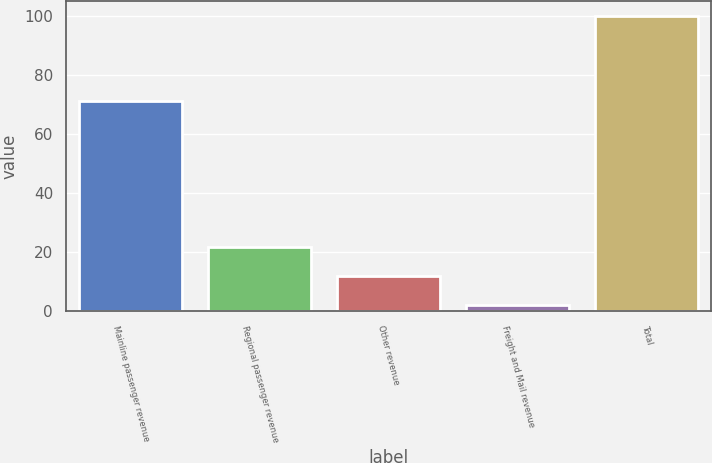Convert chart to OTSL. <chart><loc_0><loc_0><loc_500><loc_500><bar_chart><fcel>Mainline passenger revenue<fcel>Regional passenger revenue<fcel>Other revenue<fcel>Freight and Mail revenue<fcel>Total<nl><fcel>71<fcel>21.6<fcel>11.8<fcel>2<fcel>100<nl></chart> 